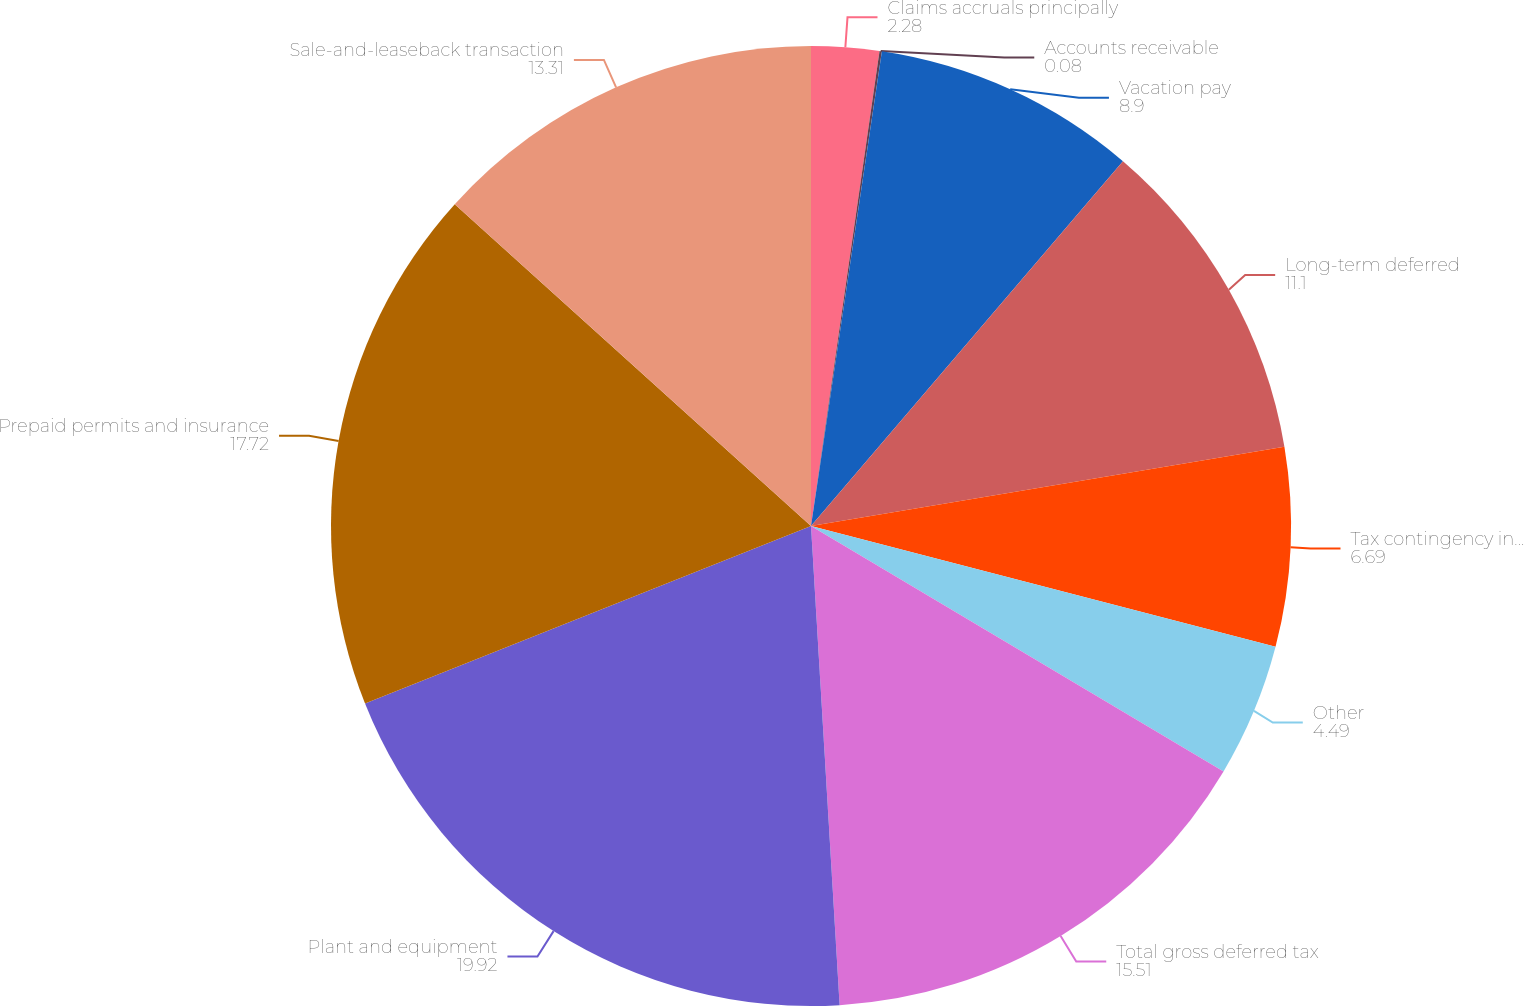<chart> <loc_0><loc_0><loc_500><loc_500><pie_chart><fcel>Claims accruals principally<fcel>Accounts receivable<fcel>Vacation pay<fcel>Long-term deferred<fcel>Tax contingency interest<fcel>Other<fcel>Total gross deferred tax<fcel>Plant and equipment<fcel>Prepaid permits and insurance<fcel>Sale-and-leaseback transaction<nl><fcel>2.28%<fcel>0.08%<fcel>8.9%<fcel>11.1%<fcel>6.69%<fcel>4.49%<fcel>15.51%<fcel>19.92%<fcel>17.72%<fcel>13.31%<nl></chart> 